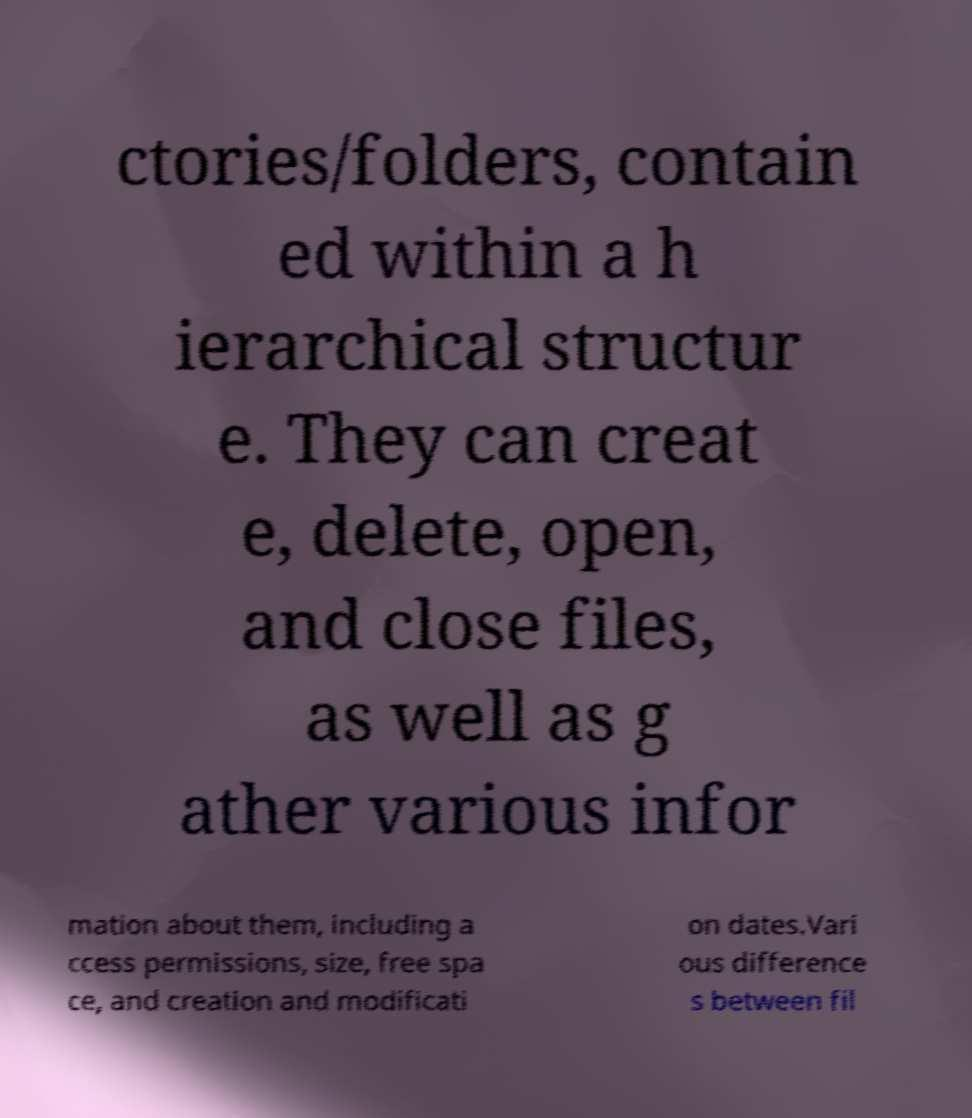Please read and relay the text visible in this image. What does it say? ctories/folders, contain ed within a h ierarchical structur e. They can creat e, delete, open, and close files, as well as g ather various infor mation about them, including a ccess permissions, size, free spa ce, and creation and modificati on dates.Vari ous difference s between fil 